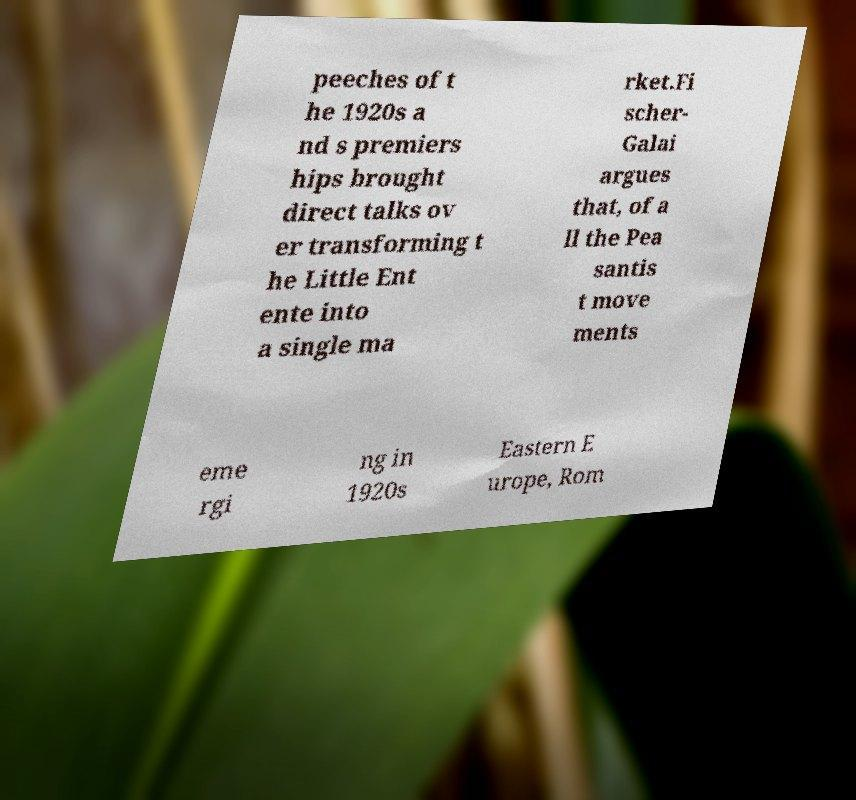Please read and relay the text visible in this image. What does it say? peeches of t he 1920s a nd s premiers hips brought direct talks ov er transforming t he Little Ent ente into a single ma rket.Fi scher- Galai argues that, of a ll the Pea santis t move ments eme rgi ng in 1920s Eastern E urope, Rom 